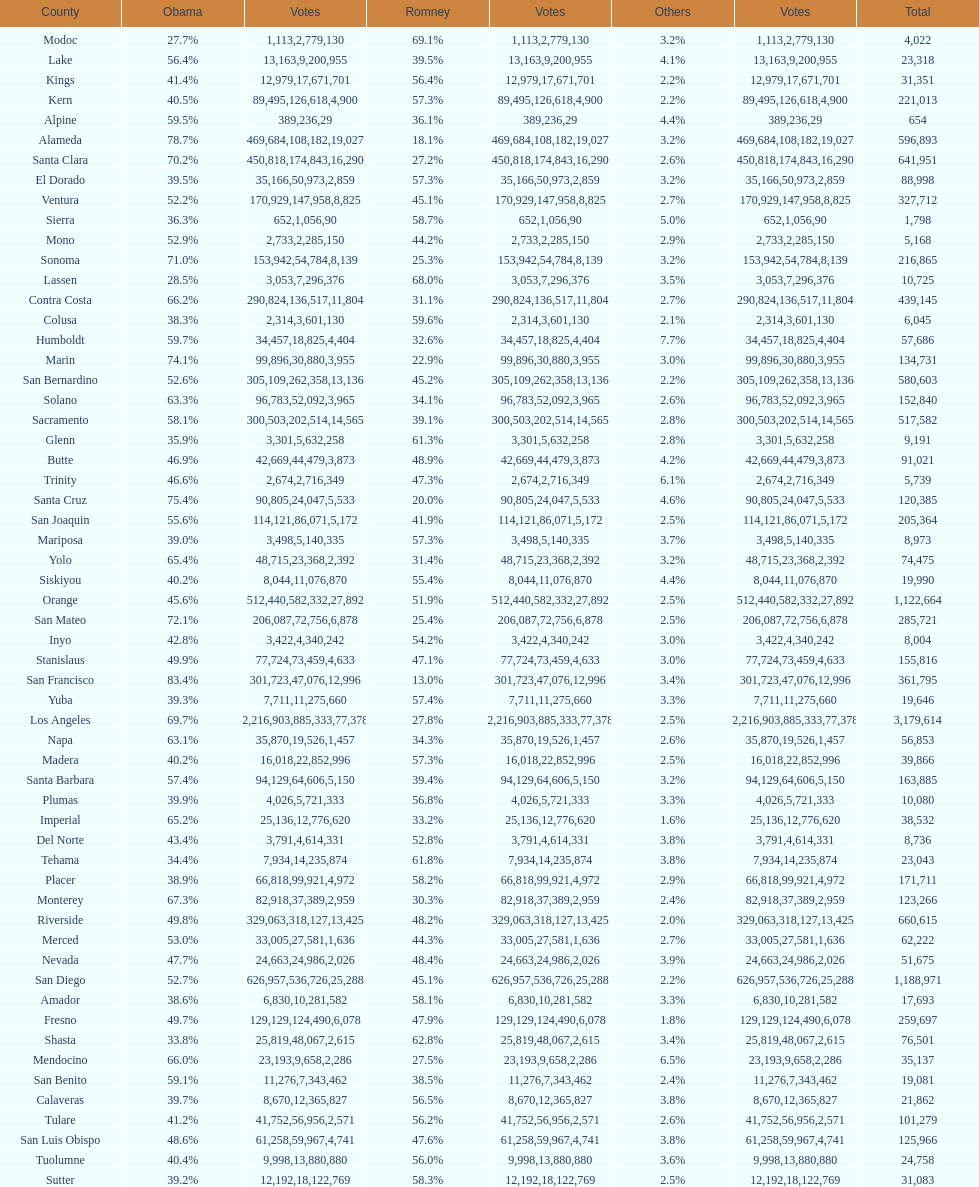How many counties had at least 75% of the votes for obama? 3. 